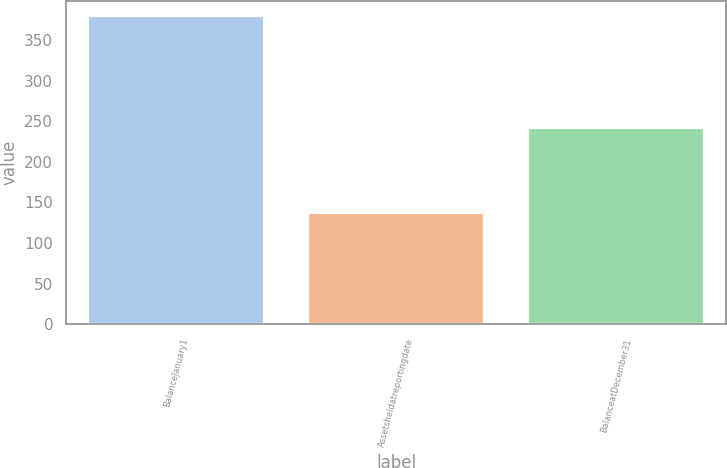Convert chart. <chart><loc_0><loc_0><loc_500><loc_500><bar_chart><fcel>BalanceJanuary1<fcel>Assetsheldatreportingdate<fcel>BalanceatDecember31<nl><fcel>379<fcel>137<fcel>242<nl></chart> 